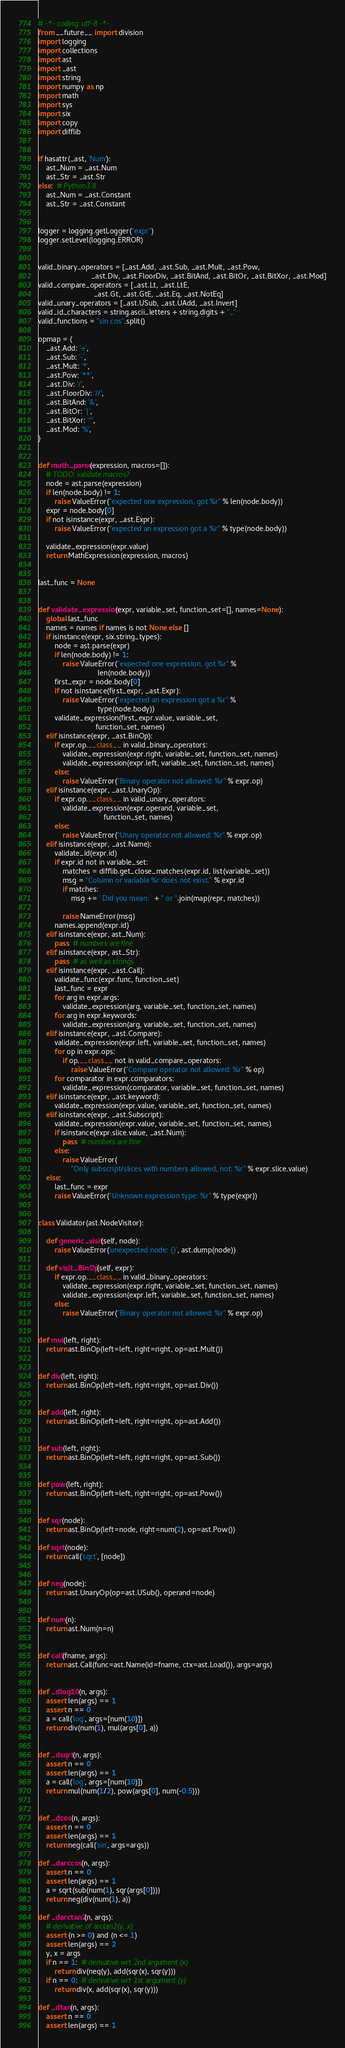<code> <loc_0><loc_0><loc_500><loc_500><_Python_># -*- coding: utf-8 -*-
from __future__ import division
import logging
import collections
import ast
import _ast
import string
import numpy as np
import math
import sys
import six
import copy
import difflib


if hasattr(_ast, 'Num'):
    ast_Num = _ast.Num
    ast_Str = _ast.Str
else:  # Python3.8
    ast_Num = _ast.Constant
    ast_Str = _ast.Constant


logger = logging.getLogger("expr")
logger.setLevel(logging.ERROR)


valid_binary_operators = [_ast.Add, _ast.Sub, _ast.Mult, _ast.Pow,
                          _ast.Div, _ast.FloorDiv, _ast.BitAnd, _ast.BitOr, _ast.BitXor, _ast.Mod]
valid_compare_operators = [_ast.Lt, _ast.LtE,
                           _ast.Gt, _ast.GtE, _ast.Eq, _ast.NotEq]
valid_unary_operators = [_ast.USub, _ast.UAdd, _ast.Invert]
valid_id_characters = string.ascii_letters + string.digits + "_"
valid_functions = "sin cos".split()

opmap = {
    _ast.Add: '+',
    _ast.Sub: '-',
    _ast.Mult: '*',
    _ast.Pow: '**',
    _ast.Div: '/',
    _ast.FloorDiv: '//',
    _ast.BitAnd: '&',
    _ast.BitOr: '|',
    _ast.BitXor: '^',
    _ast.Mod: '%',
}


def math_parse(expression, macros=[]):
    # TODO: validate macros?
    node = ast.parse(expression)
    if len(node.body) != 1:
        raise ValueError("expected one expression, got %r" % len(node.body))
    expr = node.body[0]
    if not isinstance(expr, _ast.Expr):
        raise ValueError("expected an expression got a %r" % type(node.body))

    validate_expression(expr.value)
    return MathExpression(expression, macros)


last_func = None


def validate_expression(expr, variable_set, function_set=[], names=None):
    global last_func
    names = names if names is not None else []
    if isinstance(expr, six.string_types):
        node = ast.parse(expr)
        if len(node.body) != 1:
            raise ValueError("expected one expression, got %r" %
                             len(node.body))
        first_expr = node.body[0]
        if not isinstance(first_expr, _ast.Expr):
            raise ValueError("expected an expression got a %r" %
                             type(node.body))
        validate_expression(first_expr.value, variable_set,
                            function_set, names)
    elif isinstance(expr, _ast.BinOp):
        if expr.op.__class__ in valid_binary_operators:
            validate_expression(expr.right, variable_set, function_set, names)
            validate_expression(expr.left, variable_set, function_set, names)
        else:
            raise ValueError("Binary operator not allowed: %r" % expr.op)
    elif isinstance(expr, _ast.UnaryOp):
        if expr.op.__class__ in valid_unary_operators:
            validate_expression(expr.operand, variable_set,
                                function_set, names)
        else:
            raise ValueError("Unary operator not allowed: %r" % expr.op)
    elif isinstance(expr, _ast.Name):
        validate_id(expr.id)
        if expr.id not in variable_set:
            matches = difflib.get_close_matches(expr.id, list(variable_set))
            msg = "Column or variable %r does not exist." % expr.id
            if matches:
                msg += ' Did you mean: ' + " or ".join(map(repr, matches))

            raise NameError(msg)
        names.append(expr.id)
    elif isinstance(expr, ast_Num):
        pass  # numbers are fine
    elif isinstance(expr, ast_Str):
        pass  # as well as strings
    elif isinstance(expr, _ast.Call):
        validate_func(expr.func, function_set)
        last_func = expr
        for arg in expr.args:
            validate_expression(arg, variable_set, function_set, names)
        for arg in expr.keywords:
            validate_expression(arg, variable_set, function_set, names)
    elif isinstance(expr, _ast.Compare):
        validate_expression(expr.left, variable_set, function_set, names)
        for op in expr.ops:
            if op.__class__ not in valid_compare_operators:
                raise ValueError("Compare operator not allowed: %r" % op)
        for comparator in expr.comparators:
            validate_expression(comparator, variable_set, function_set, names)
    elif isinstance(expr, _ast.keyword):
        validate_expression(expr.value, variable_set, function_set, names)
    elif isinstance(expr, _ast.Subscript):
        validate_expression(expr.value, variable_set, function_set, names)
        if isinstance(expr.slice.value, _ast.Num):
            pass  # numbers are fine
        else:
            raise ValueError(
                "Only subscript/slices with numbers allowed, not: %r" % expr.slice.value)
    else:
        last_func = expr
        raise ValueError("Unknown expression type: %r" % type(expr))


class Validator(ast.NodeVisitor):

    def generic_visit(self, node):
        raise ValueError('unexpected node: {}', ast.dump(node))

    def visit_BinOp(self, expr):
        if expr.op.__class__ in valid_binary_operators:
            validate_expression(expr.right, variable_set, function_set, names)
            validate_expression(expr.left, variable_set, function_set, names)
        else:
            raise ValueError("Binary operator not allowed: %r" % expr.op)


def mul(left, right):
    return ast.BinOp(left=left, right=right, op=ast.Mult())


def div(left, right):
    return ast.BinOp(left=left, right=right, op=ast.Div())


def add(left, right):
    return ast.BinOp(left=left, right=right, op=ast.Add())


def sub(left, right):
    return ast.BinOp(left=left, right=right, op=ast.Sub())


def pow(left, right):
    return ast.BinOp(left=left, right=right, op=ast.Pow())


def sqr(node):
    return ast.BinOp(left=node, right=num(2), op=ast.Pow())

def sqrt(node):
    return call('sqrt', [node])


def neg(node):
    return ast.UnaryOp(op=ast.USub(), operand=node)


def num(n):
    return ast.Num(n=n)


def call(fname, args):
    return ast.Call(func=ast.Name(id=fname, ctx=ast.Load()), args=args)


def _dlog10(n, args):
    assert len(args) == 1
    assert n == 0
    a = call('log', args=[num(10)])
    return div(num(1), mul(args[0], a))


def _dsqrt(n, args):
    assert n == 0
    assert len(args) == 1
    a = call('log', args=[num(10)])
    return mul(num(1/2), pow(args[0], num(-0.5)))


def _dcos(n, args):
    assert n == 0
    assert len(args) == 1
    return neg(call('sin', args=args))

def _darccos(n, args):
    assert n == 0
    assert len(args) == 1
    a = sqrt(sub(num(1), sqr(args[0])))
    return neg(div(num(1), a))

def _darctan2(n, args):
    # derivative of arctan2(y, x)
    assert (n >= 0) and (n <= 1)
    assert len(args) == 2
    y, x = args
    if n == 1:  # derivative wrt 2nd argument (x)
        return div(neg(y), add(sqr(x), sqr(y)))
    if n == 0:  # derivative wrt 1st argument (y)
        return div(x, add(sqr(x), sqr(y)))

def _dtan(n, args):
    assert n == 0
    assert len(args) == 1</code> 